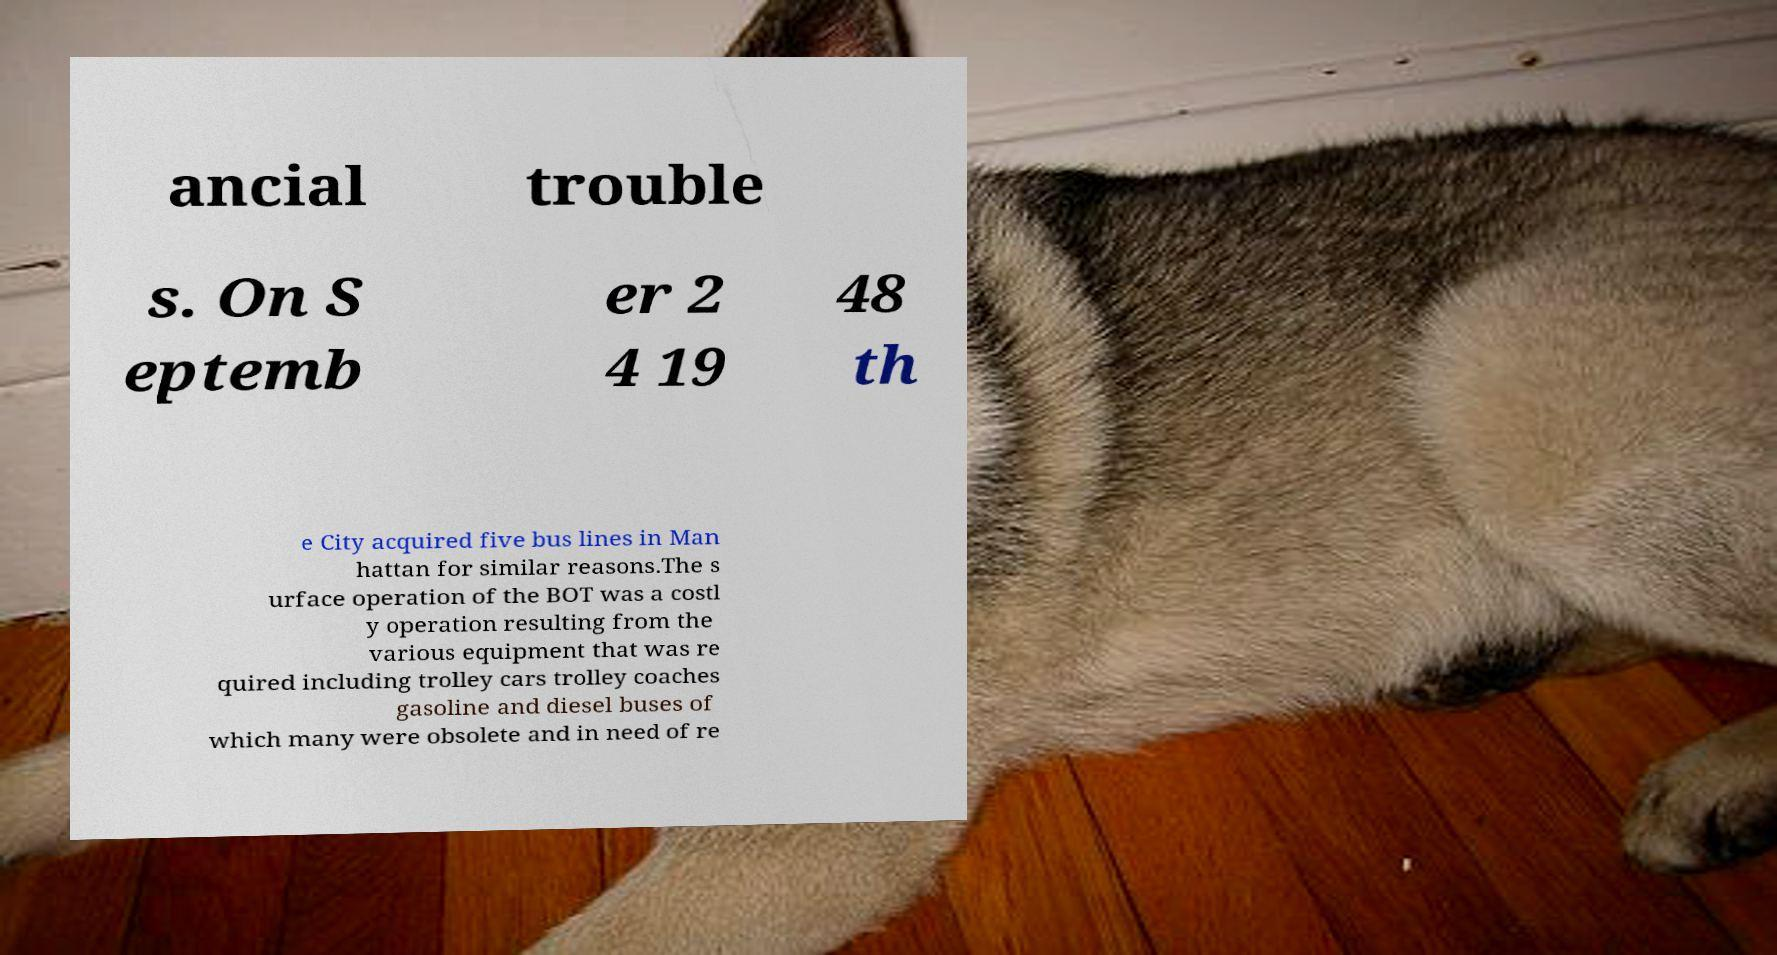Could you assist in decoding the text presented in this image and type it out clearly? ancial trouble s. On S eptemb er 2 4 19 48 th e City acquired five bus lines in Man hattan for similar reasons.The s urface operation of the BOT was a costl y operation resulting from the various equipment that was re quired including trolley cars trolley coaches gasoline and diesel buses of which many were obsolete and in need of re 